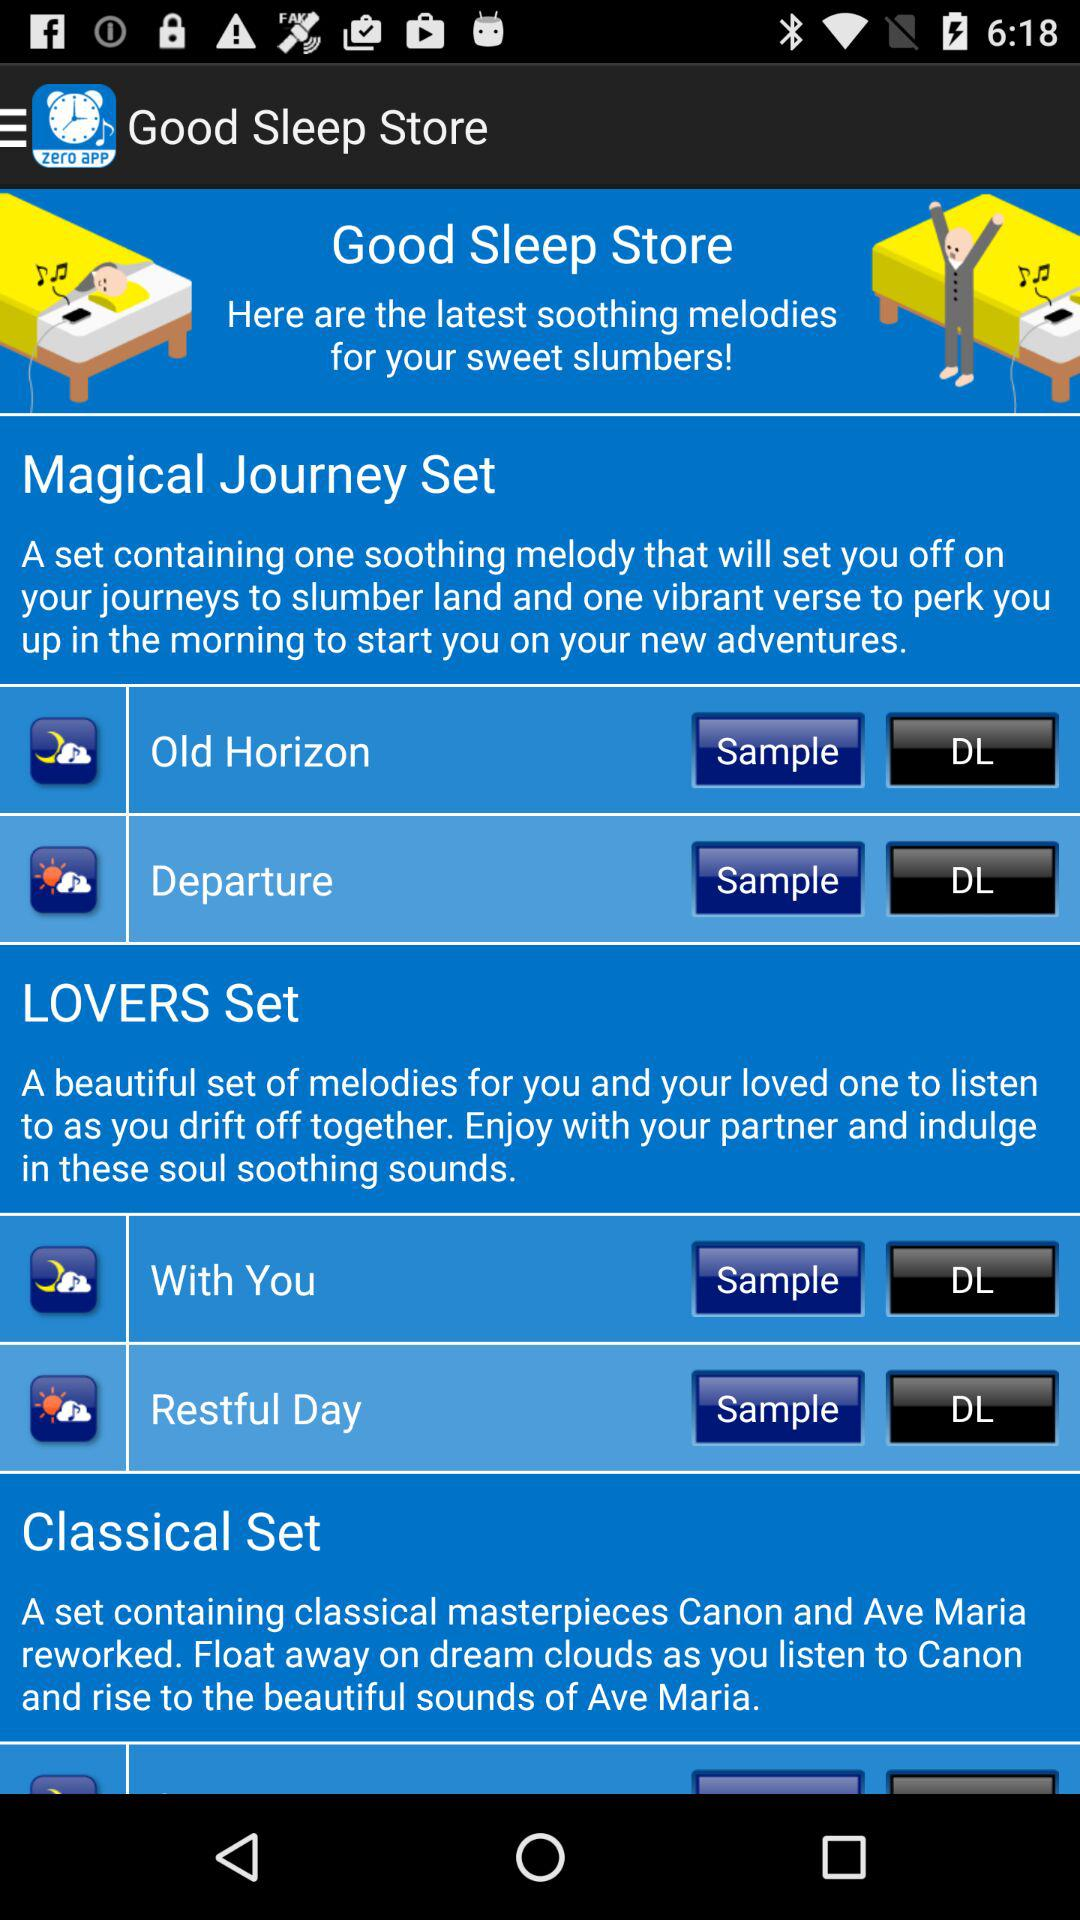Which are the two melody in the Magical journey set?
When the provided information is insufficient, respond with <no answer>. <no answer> 